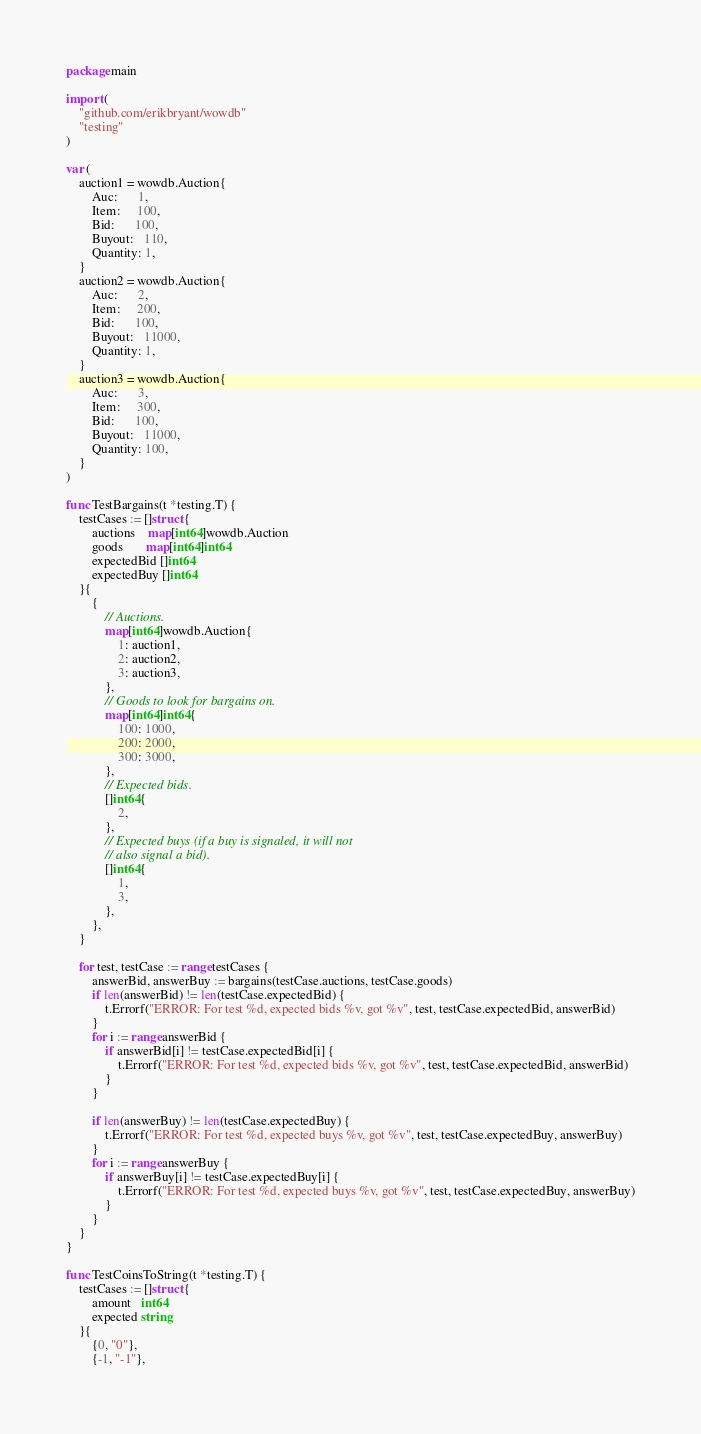Convert code to text. <code><loc_0><loc_0><loc_500><loc_500><_Go_>package main

import (
	"github.com/erikbryant/wowdb"
	"testing"
)

var (
	auction1 = wowdb.Auction{
		Auc:      1,
		Item:     100,
		Bid:      100,
		Buyout:   110,
		Quantity: 1,
	}
	auction2 = wowdb.Auction{
		Auc:      2,
		Item:     200,
		Bid:      100,
		Buyout:   11000,
		Quantity: 1,
	}
	auction3 = wowdb.Auction{
		Auc:      3,
		Item:     300,
		Bid:      100,
		Buyout:   11000,
		Quantity: 100,
	}
)

func TestBargains(t *testing.T) {
	testCases := []struct {
		auctions    map[int64]wowdb.Auction
		goods       map[int64]int64
		expectedBid []int64
		expectedBuy []int64
	}{
		{
			// Auctions.
			map[int64]wowdb.Auction{
				1: auction1,
				2: auction2,
				3: auction3,
			},
			// Goods to look for bargains on.
			map[int64]int64{
				100: 1000,
				200: 2000,
				300: 3000,
			},
			// Expected bids.
			[]int64{
				2,
			},
			// Expected buys (if a buy is signaled, it will not
			// also signal a bid).
			[]int64{
				1,
				3,
			},
		},
	}

	for test, testCase := range testCases {
		answerBid, answerBuy := bargains(testCase.auctions, testCase.goods)
		if len(answerBid) != len(testCase.expectedBid) {
			t.Errorf("ERROR: For test %d, expected bids %v, got %v", test, testCase.expectedBid, answerBid)
		}
		for i := range answerBid {
			if answerBid[i] != testCase.expectedBid[i] {
				t.Errorf("ERROR: For test %d, expected bids %v, got %v", test, testCase.expectedBid, answerBid)
			}
		}

		if len(answerBuy) != len(testCase.expectedBuy) {
			t.Errorf("ERROR: For test %d, expected buys %v, got %v", test, testCase.expectedBuy, answerBuy)
		}
		for i := range answerBuy {
			if answerBuy[i] != testCase.expectedBuy[i] {
				t.Errorf("ERROR: For test %d, expected buys %v, got %v", test, testCase.expectedBuy, answerBuy)
			}
		}
	}
}

func TestCoinsToString(t *testing.T) {
	testCases := []struct {
		amount   int64
		expected string
	}{
		{0, "0"},
		{-1, "-1"},</code> 